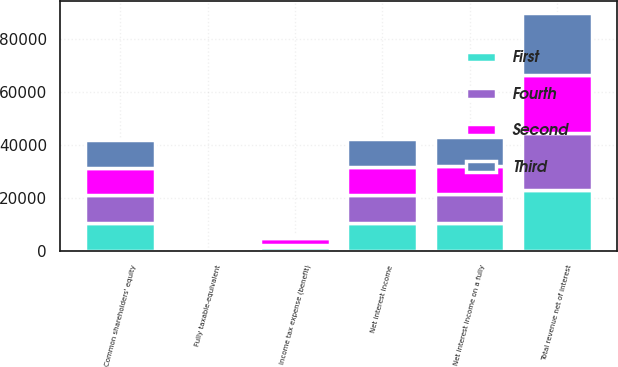Convert chart to OTSL. <chart><loc_0><loc_0><loc_500><loc_500><stacked_bar_chart><ecel><fcel>Net interest income<fcel>Fully taxable-equivalent<fcel>Net interest income on a fully<fcel>Total revenue net of interest<fcel>Income tax expense (benefit)<fcel>Common shareholders' equity<nl><fcel>Fourth<fcel>10786<fcel>213<fcel>10999<fcel>21701<fcel>619<fcel>10514<nl><fcel>Second<fcel>10266<fcel>213<fcel>10479<fcel>21743<fcel>2561<fcel>10514<nl><fcel>First<fcel>10549<fcel>222<fcel>10771<fcel>22949<fcel>1708<fcel>10514<nl><fcel>Third<fcel>10664<fcel>211<fcel>10875<fcel>23408<fcel>712<fcel>10514<nl></chart> 